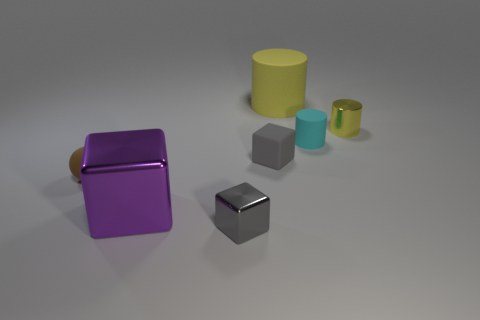Subtract all rubber cylinders. How many cylinders are left? 1 Subtract all cyan cylinders. How many cylinders are left? 2 Subtract all balls. How many objects are left? 6 Add 2 brown rubber objects. How many objects exist? 9 Subtract all blue cubes. Subtract all green spheres. How many cubes are left? 3 Subtract all purple cubes. How many green spheres are left? 0 Subtract all matte objects. Subtract all big gray matte objects. How many objects are left? 3 Add 7 matte cylinders. How many matte cylinders are left? 9 Add 5 large purple metal cubes. How many large purple metal cubes exist? 6 Subtract 0 red cylinders. How many objects are left? 7 